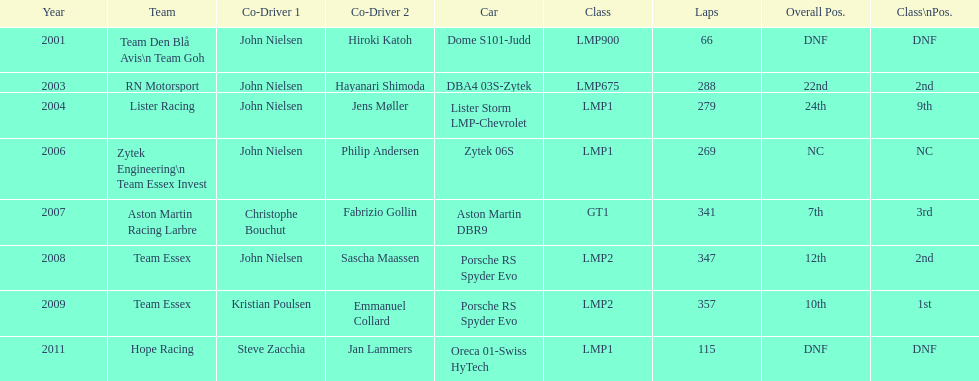What model car was the most used? Porsche RS Spyder. 